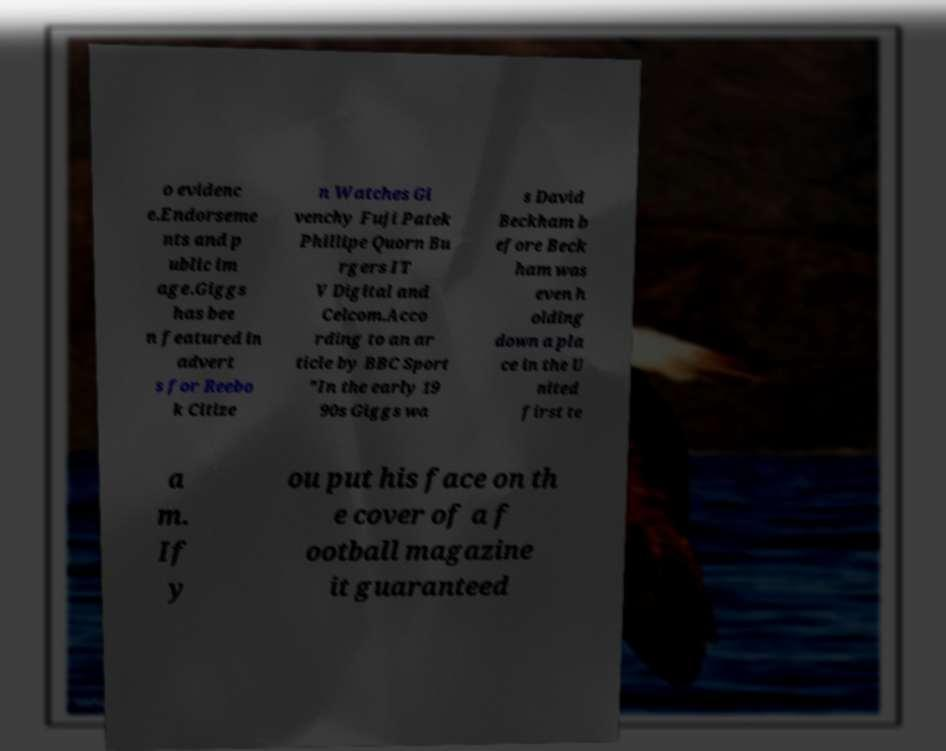Could you assist in decoding the text presented in this image and type it out clearly? o evidenc e.Endorseme nts and p ublic im age.Giggs has bee n featured in advert s for Reebo k Citize n Watches Gi venchy Fuji Patek Phillipe Quorn Bu rgers IT V Digital and Celcom.Acco rding to an ar ticle by BBC Sport "In the early 19 90s Giggs wa s David Beckham b efore Beck ham was even h olding down a pla ce in the U nited first te a m. If y ou put his face on th e cover of a f ootball magazine it guaranteed 